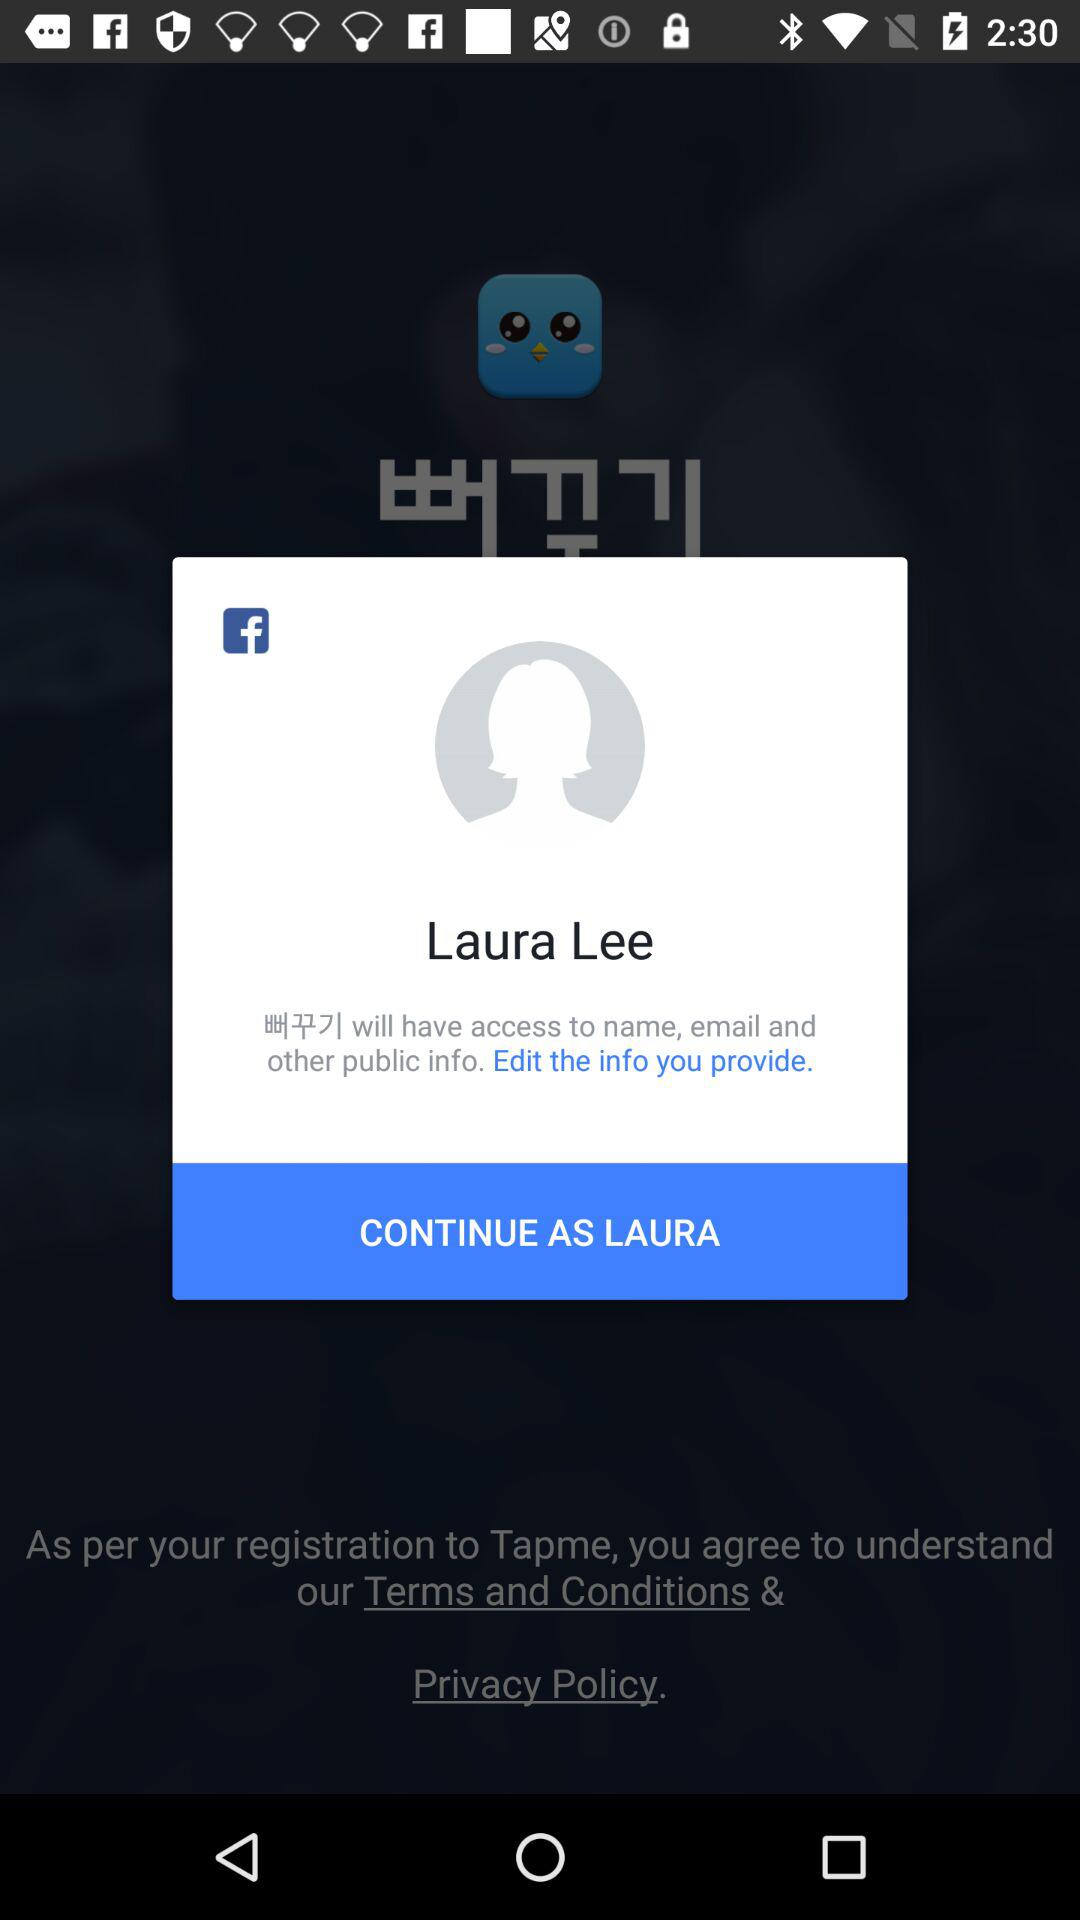How many public information fields will Laura Lee have access to?
Answer the question using a single word or phrase. 3 